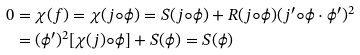Convert formula to latex. <formula><loc_0><loc_0><loc_500><loc_500>0 & = \chi ( f ) = \chi ( j \circ \phi ) = S ( j \circ \phi ) + R ( j \circ \phi ) ( j ^ { \prime } \circ \phi \cdot \phi ^ { \prime } ) ^ { 2 } \\ & = ( \phi ^ { \prime } ) ^ { 2 } [ \chi ( j ) \circ \phi ] + S ( \phi ) = S ( \phi )</formula> 